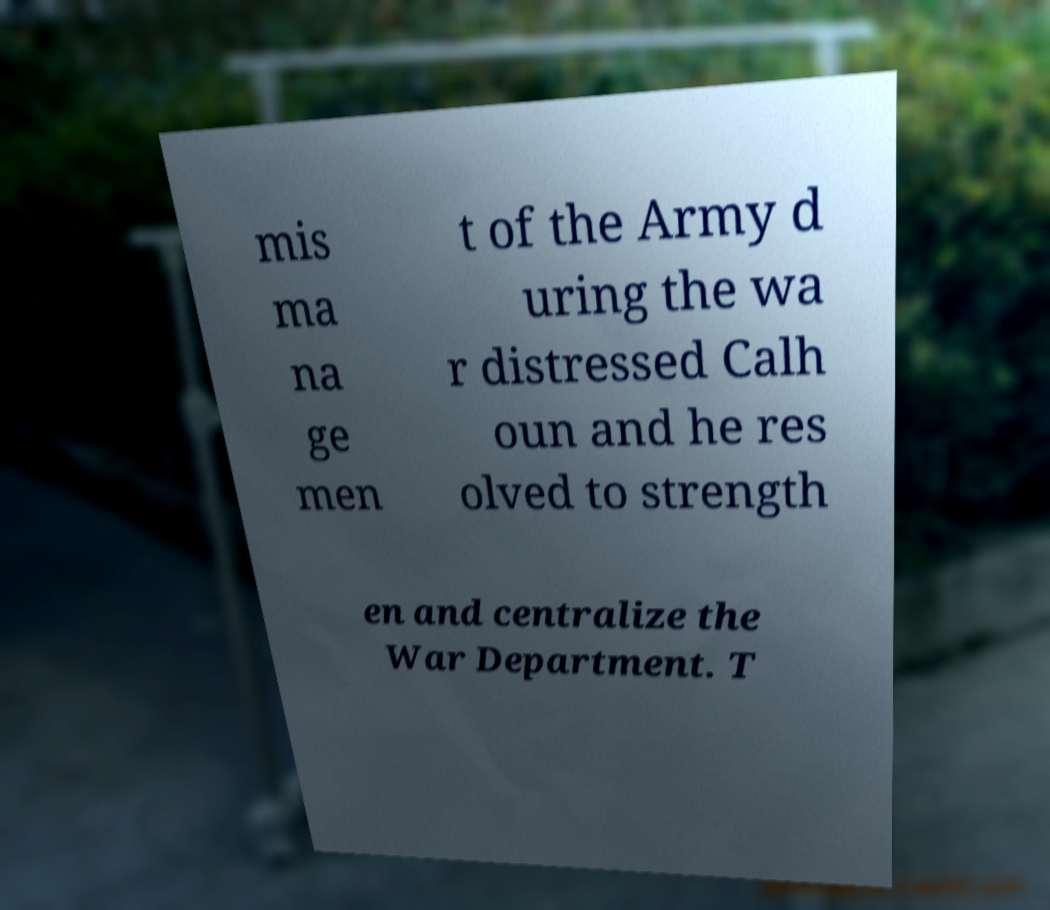For documentation purposes, I need the text within this image transcribed. Could you provide that? mis ma na ge men t of the Army d uring the wa r distressed Calh oun and he res olved to strength en and centralize the War Department. T 